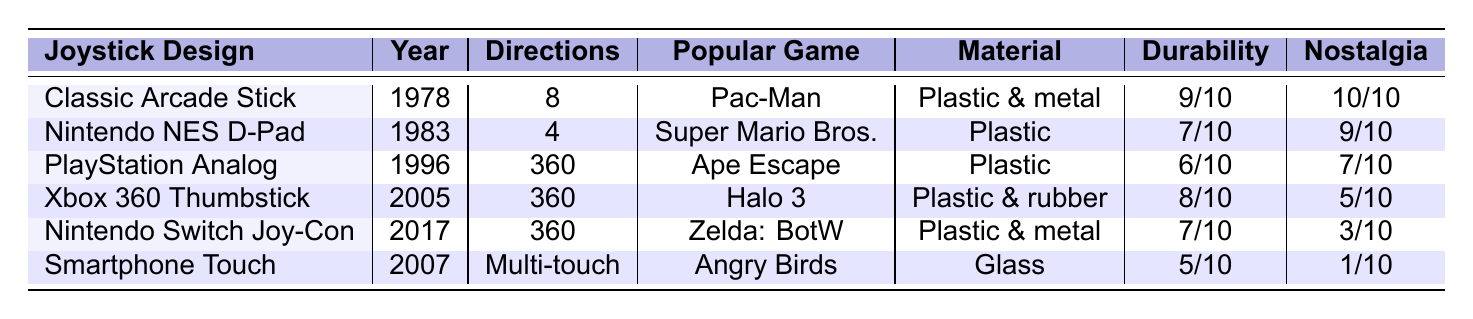What is the year when the Nintendo Switch Joy-Con was introduced? The table shows that the Nintendo Switch Joy-Con was introduced in the year 2017.
Answer: 2017 Which joystick design has the highest durability rating? The Classic Arcade Stick has a durability rating of 9, which is the highest among all listed designs.
Answer: Classic Arcade Stick What is the material used for the Smartphone Touch Controls? According to the table, the material used for Smartphone Touch Controls is Glass.
Answer: Glass How many joystick designs allow for full 360-degree movement? The joystick designs that allow for full 360-degree movement are PlayStation Analog Stick, Xbox 360 Thumbstick, and Nintendo Switch Joy-Con, making a total of 3 designs.
Answer: 3 Is the Nintendo NES D-Pad compatible with classic games? Yes, the compatibility with classic games for the Nintendo NES D-Pad is rated as "Good."
Answer: Yes What is the average nostalgia factor rating for all the joystick designs? To find the average nostalgia factor, add the ratings (10 + 9 + 7 + 5 + 3 + 1 = 35) and divide by the number of designs (35/6 = 5.83). The average nostalgia factor is approximately 5.83.
Answer: 5.83 Which joystick design has the lowest learning curve? The Smartphone Touch Controls have the highest learning curve rating of 7, making it the lowest compared to other joystick designs that are easier to learn.
Answer: Smartphone Touch Controls What is the difference in durability between the Classic Arcade Stick and the Smartphone Touch Controls? The durability for the Classic Arcade Stick is 9/10 and for the Smartphone Touch Controls, it is 5/10. The difference is 9 - 5 = 4.
Answer: 4 How many joystick designs can be classified as "poor" in compatibility with classic games? The table shows that the Xbox 360 Thumbstick, Nintendo Switch Joy-Con, and Smartphone Touch Controls are rated "Poor" in compatibility, totaling 3 designs.
Answer: 3 Which joystick has a nostalgia factor rating of 3 and what popular game is associated with it? The Nintendo Switch Joy-Con has a nostalgia factor rating of 3, and it is associated with the popular game "The Legend of Zelda: Breath of the Wild."
Answer: Nintendo Switch Joy-Con and The Legend of Zelda: Breath of the Wild 